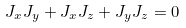Convert formula to latex. <formula><loc_0><loc_0><loc_500><loc_500>J _ { x } J _ { y } + J _ { x } J _ { z } + J _ { y } J _ { z } = 0</formula> 